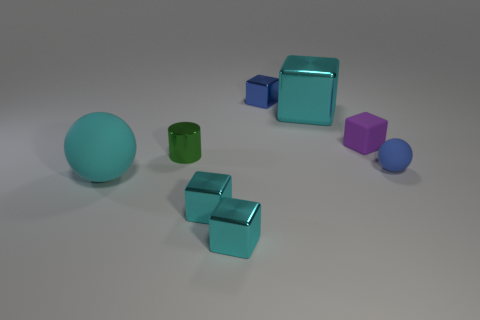Subtract all cyan blocks. How many were subtracted if there are1cyan blocks left? 2 Subtract all brown balls. How many cyan blocks are left? 3 Subtract all small blue blocks. How many blocks are left? 4 Subtract all purple blocks. How many blocks are left? 4 Subtract all gray blocks. Subtract all yellow cylinders. How many blocks are left? 5 Add 1 red shiny spheres. How many objects exist? 9 Subtract all balls. How many objects are left? 6 Subtract 3 cyan blocks. How many objects are left? 5 Subtract all large blue matte cylinders. Subtract all big balls. How many objects are left? 7 Add 5 blue rubber spheres. How many blue rubber spheres are left? 6 